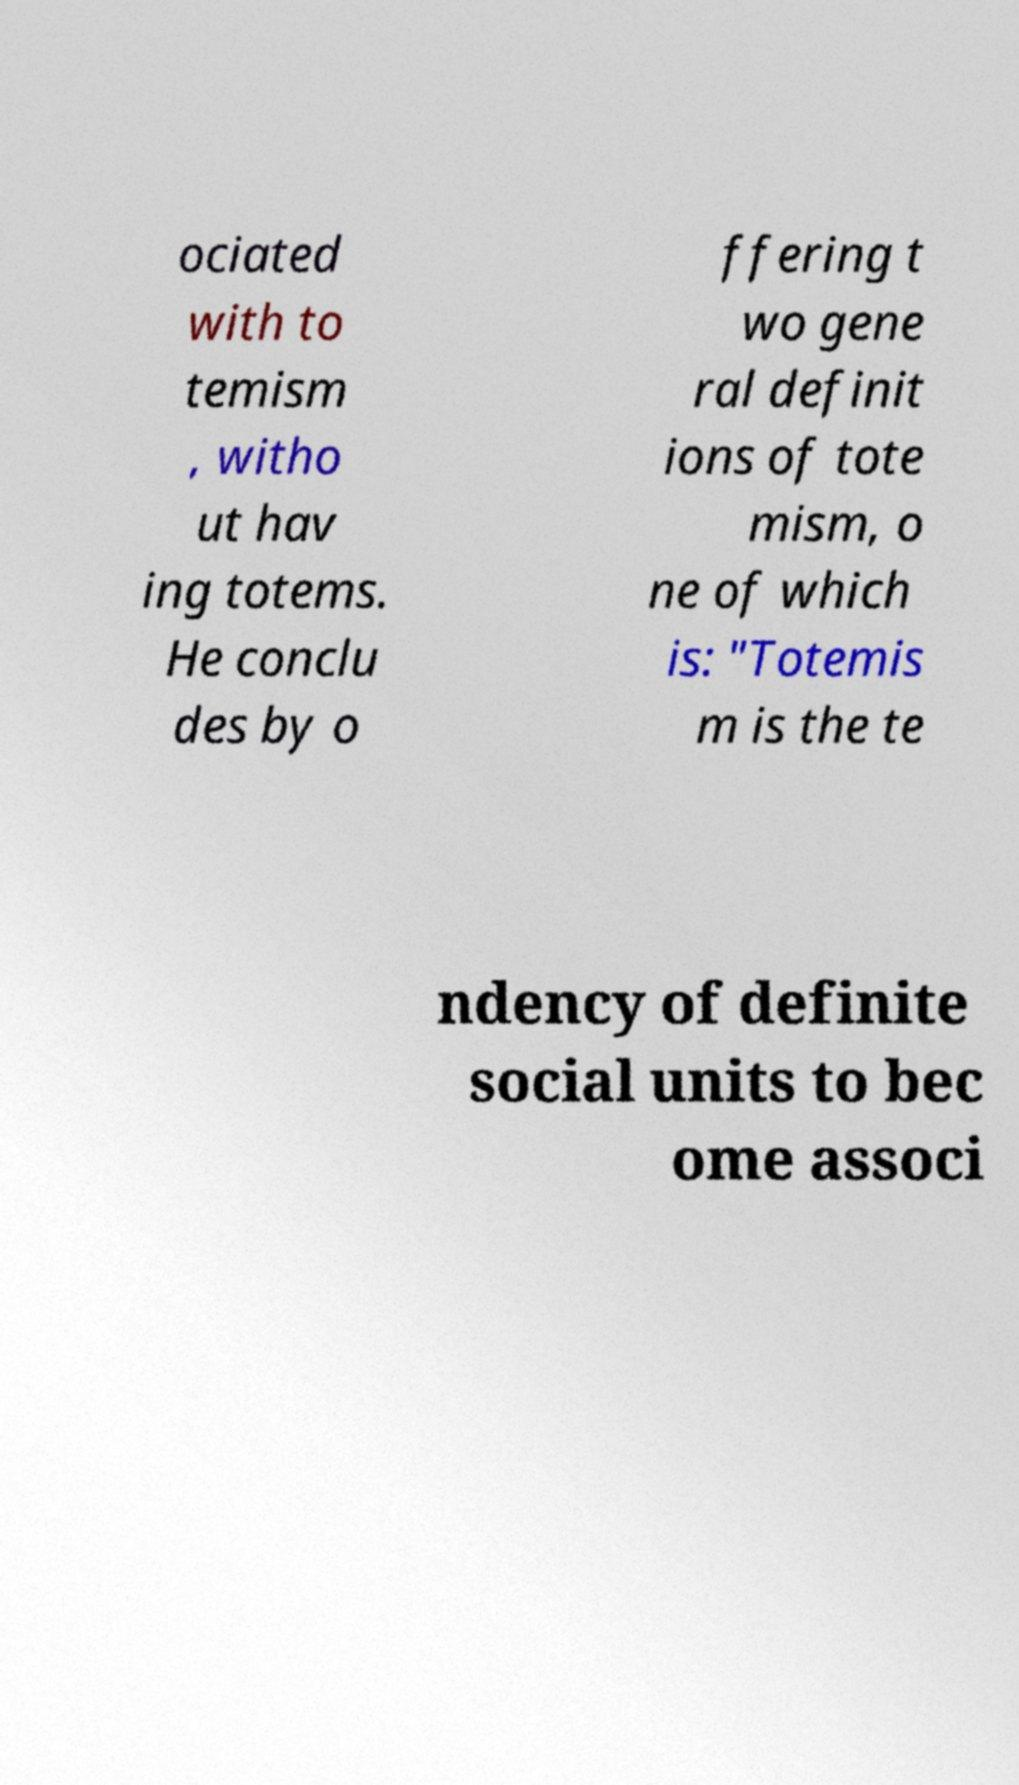Could you extract and type out the text from this image? ociated with to temism , witho ut hav ing totems. He conclu des by o ffering t wo gene ral definit ions of tote mism, o ne of which is: "Totemis m is the te ndency of definite social units to bec ome associ 